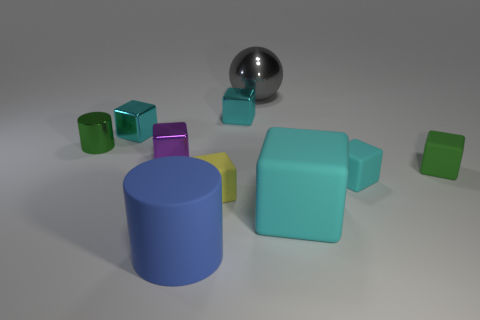What is the color of the metal block on the right side of the cylinder on the right side of the tiny cylinder?
Provide a succinct answer. Cyan. There is a metallic cylinder; does it have the same color as the large object behind the metallic cylinder?
Your response must be concise. No. The block that is to the left of the blue matte cylinder and behind the small purple shiny object is made of what material?
Give a very brief answer. Metal. Is there a blue cylinder of the same size as the purple object?
Keep it short and to the point. No. What is the material of the cyan object that is the same size as the gray shiny sphere?
Your answer should be compact. Rubber. There is a tiny yellow rubber object; what number of small yellow matte things are left of it?
Provide a short and direct response. 0. Do the tiny cyan object that is in front of the small purple thing and the small purple shiny thing have the same shape?
Ensure brevity in your answer.  Yes. Is there another thing of the same shape as the tiny green rubber thing?
Ensure brevity in your answer.  Yes. What material is the thing that is the same color as the metallic cylinder?
Give a very brief answer. Rubber. There is a large matte object in front of the large object that is to the right of the big gray shiny thing; what is its shape?
Provide a succinct answer. Cylinder. 